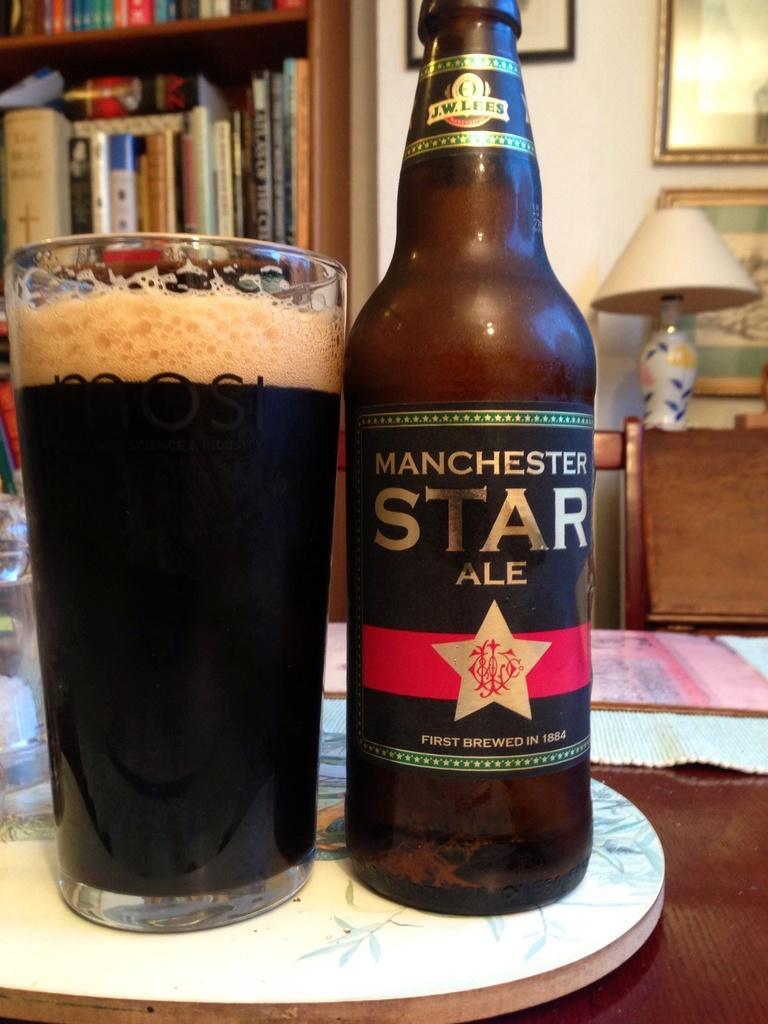How would you summarize this image in a sentence or two? In this image we can see the bottle and glass with a drink on the table. And there are mats and glass on the table. And at the side there is a chair near the table. At the back there are photo frames attached to the wall. There are different types of books arranged in racks. 